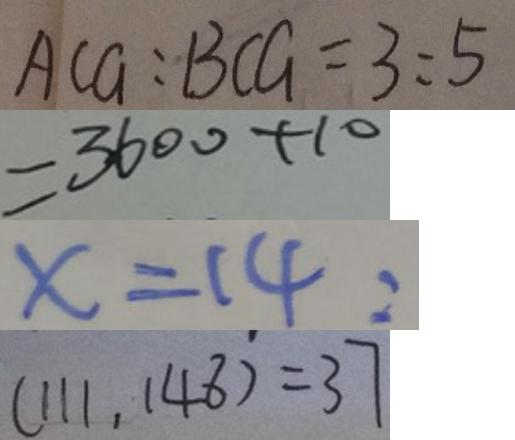Convert formula to latex. <formula><loc_0><loc_0><loc_500><loc_500>A C G : B C G = 3 : 5 
 = 3 6 0 0 + 1 0 
 x = 1 4 : 
 ( 1 1 1 , 1 4 8 ) = 3 7</formula> 